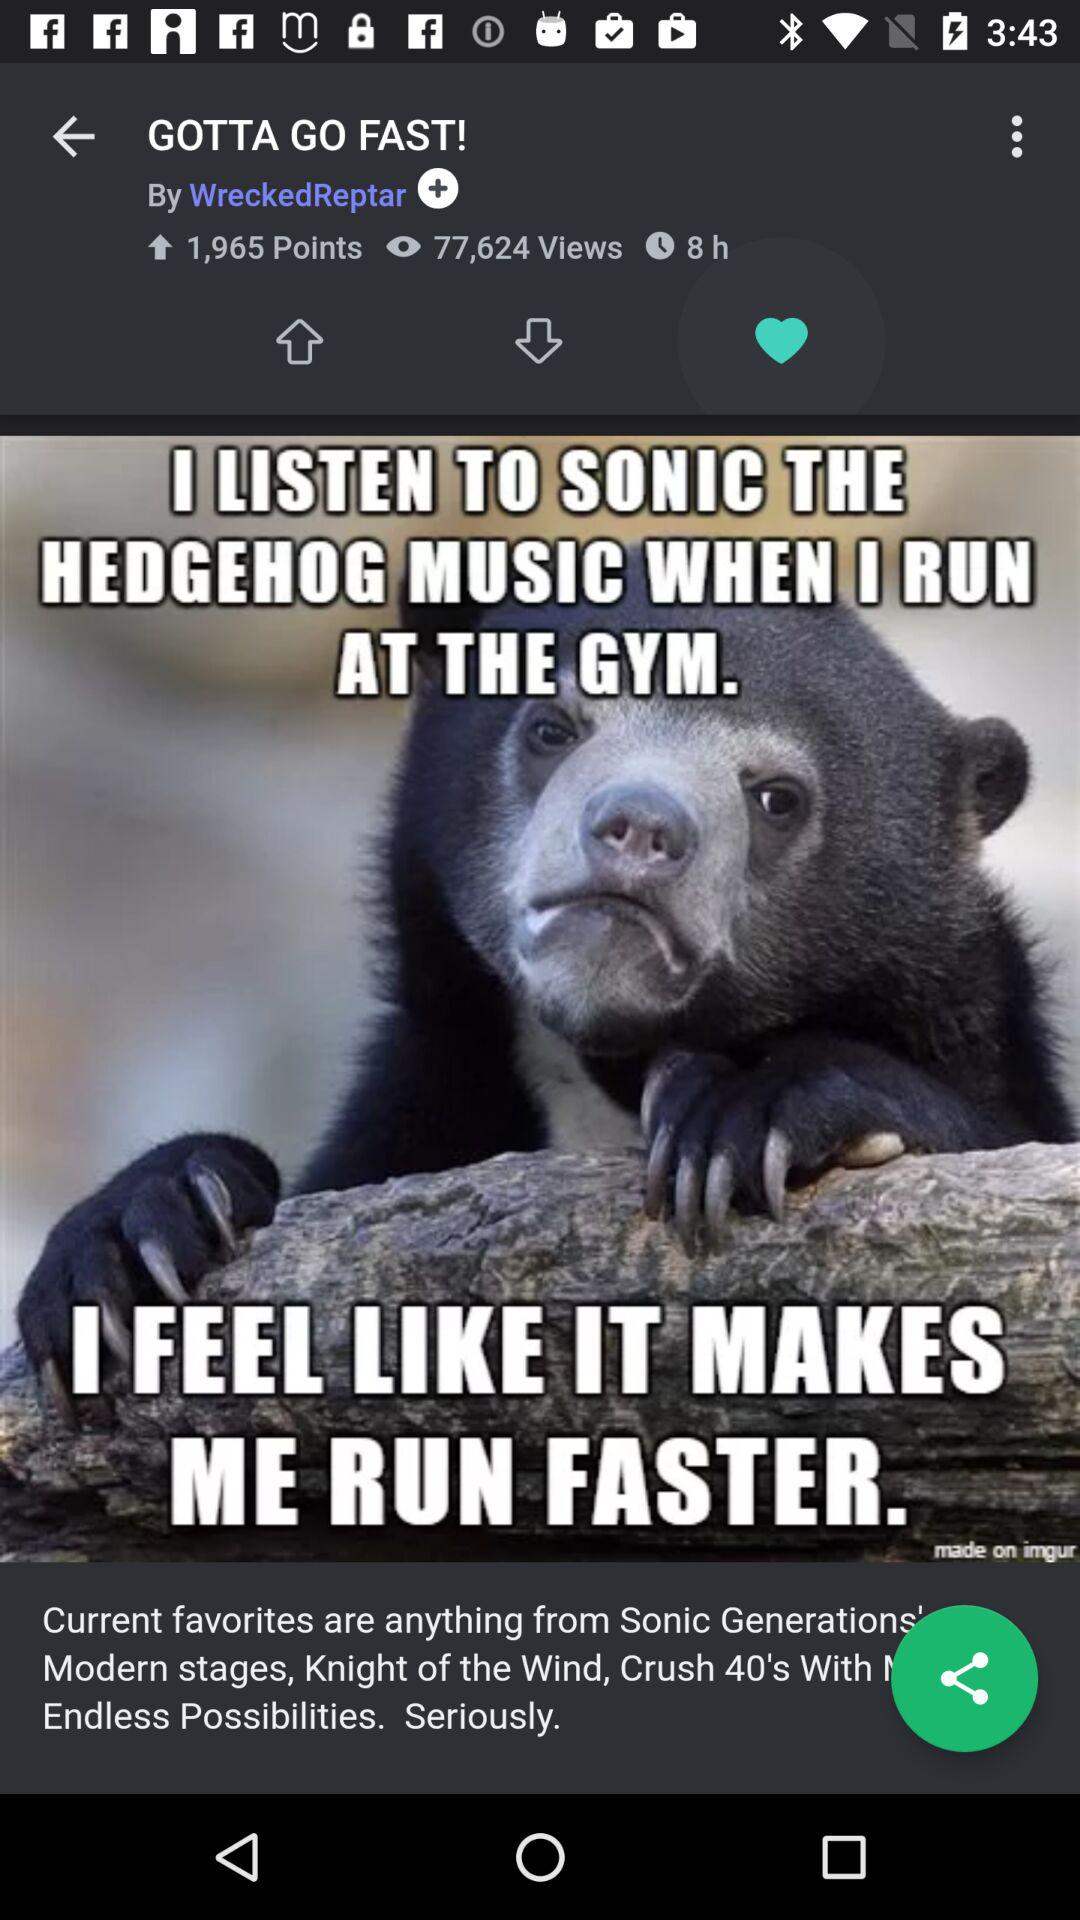How many views are there for the post?
Answer the question using a single word or phrase. 77,624 